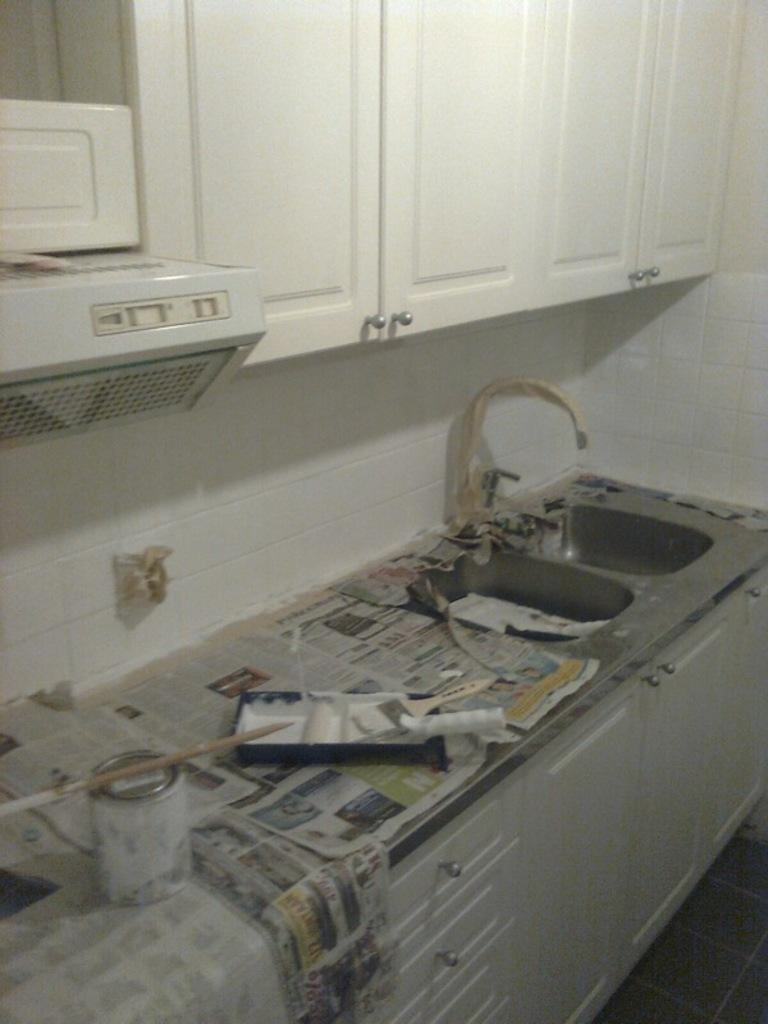What is the main object in the image? There is a paint box in the image. What tools are present for using the paint? There are brushes in the image. What can be seen for reading or covering surfaces? There are newspapers in the image. Where can one find a water source in the image? There is a sink with a tap in the image. How are the supplies organized in the image? There are wooden drawers in the image. What architectural feature is visible in the image? There is a chimney in the image. What type of cupboards are present in the image? There are white color wooden cupboards in the image. What type of jar is used for cooking stew in the image? There is no jar or stew present in the image. Is there a hole in the image that leads to a secret underground lair? There is no hole or secret underground lair present in the image. 